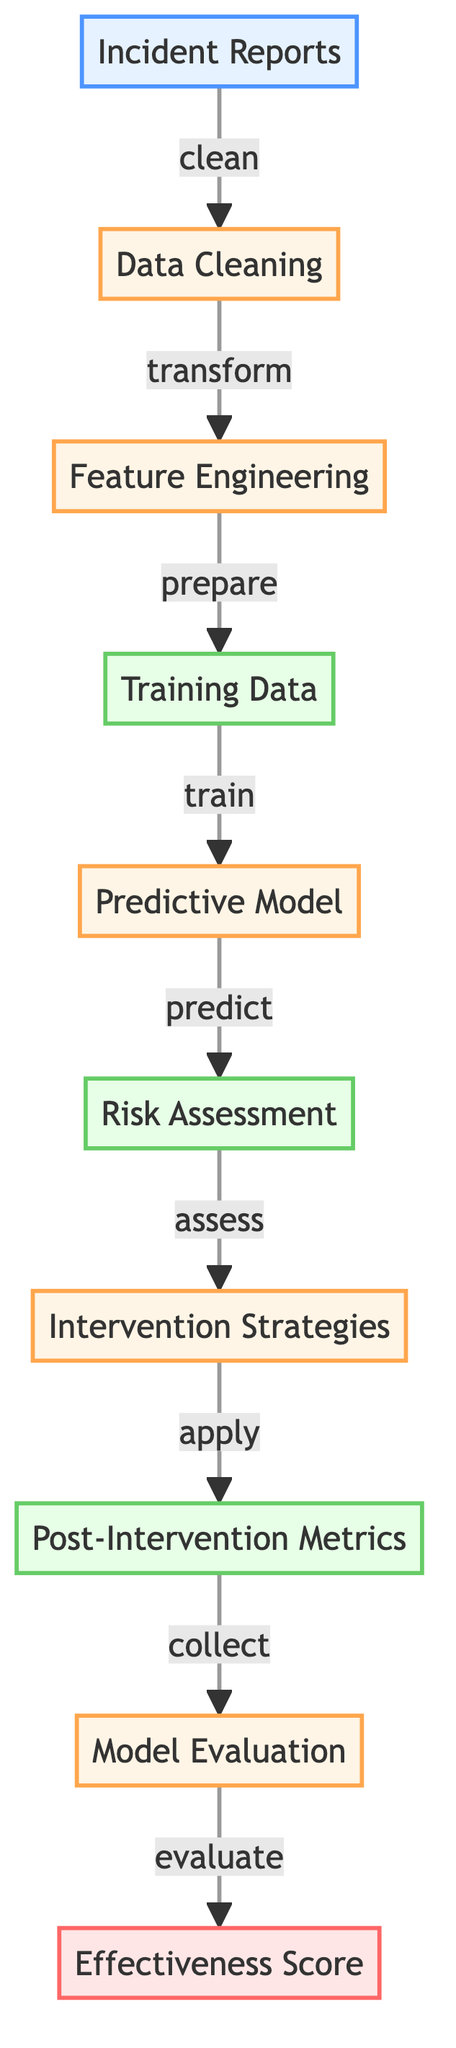What is the first step in the diagram? The first step in the diagram is "Incident Reports," which serves as the initial input for the process. This node represents the starting point, where data regarding incidents is collected.
Answer: Incident Reports How many main process nodes are in the diagram? The diagram contains five main process nodes: "Data Cleaning," "Feature Engineering," "Predictive Model," "Intervention Strategies," and "Model Evaluation." Counting these nodes gives us a total of five.
Answer: 5 What type of data is used after feature engineering? After the "Feature Engineering" step, the output is "Training Data," which is categorized as a data type in the diagram. This indicates that the data is prepared for model training.
Answer: Training Data Which node comes after "Risk Assessment"? The node that follows "Risk Assessment" in the flow is "Intervention Strategies," signifying that strategies are developed based on the assessed risks.
Answer: Intervention Strategies What is the final output of the diagram? The final output as shown in the diagram is "Effectiveness Score," which evaluates how effective the entire process has been in assessing threats and implementing interventions.
Answer: Effectiveness Score In what sequence do "Data Cleaning" and "Feature Engineering" occur? The sequence is that "Data Cleaning" occurs first as it transforms the incident reports, followed by "Feature Engineering," where the cleaned data is prepared for training. This sequence highlights the flow of data processing in the diagram.
Answer: Data Cleaning -> Feature Engineering How does "Predictive Model" relate to "Risk Assessment"? The "Predictive Model" predicts the level of risk associated with the incidents, indicating a direct relationship where the model's output feeds into the risk assessment process. This shows the dependency of risk assessment on the predictions made by the model.
Answer: Predicts What is the action taken on "Post-Intervention Metrics"? The action specified on "Post-Intervention Metrics" in the diagram is "collect," indicating that metrics are gathered after interventions have been applied to assess their impact.
Answer: Collect 